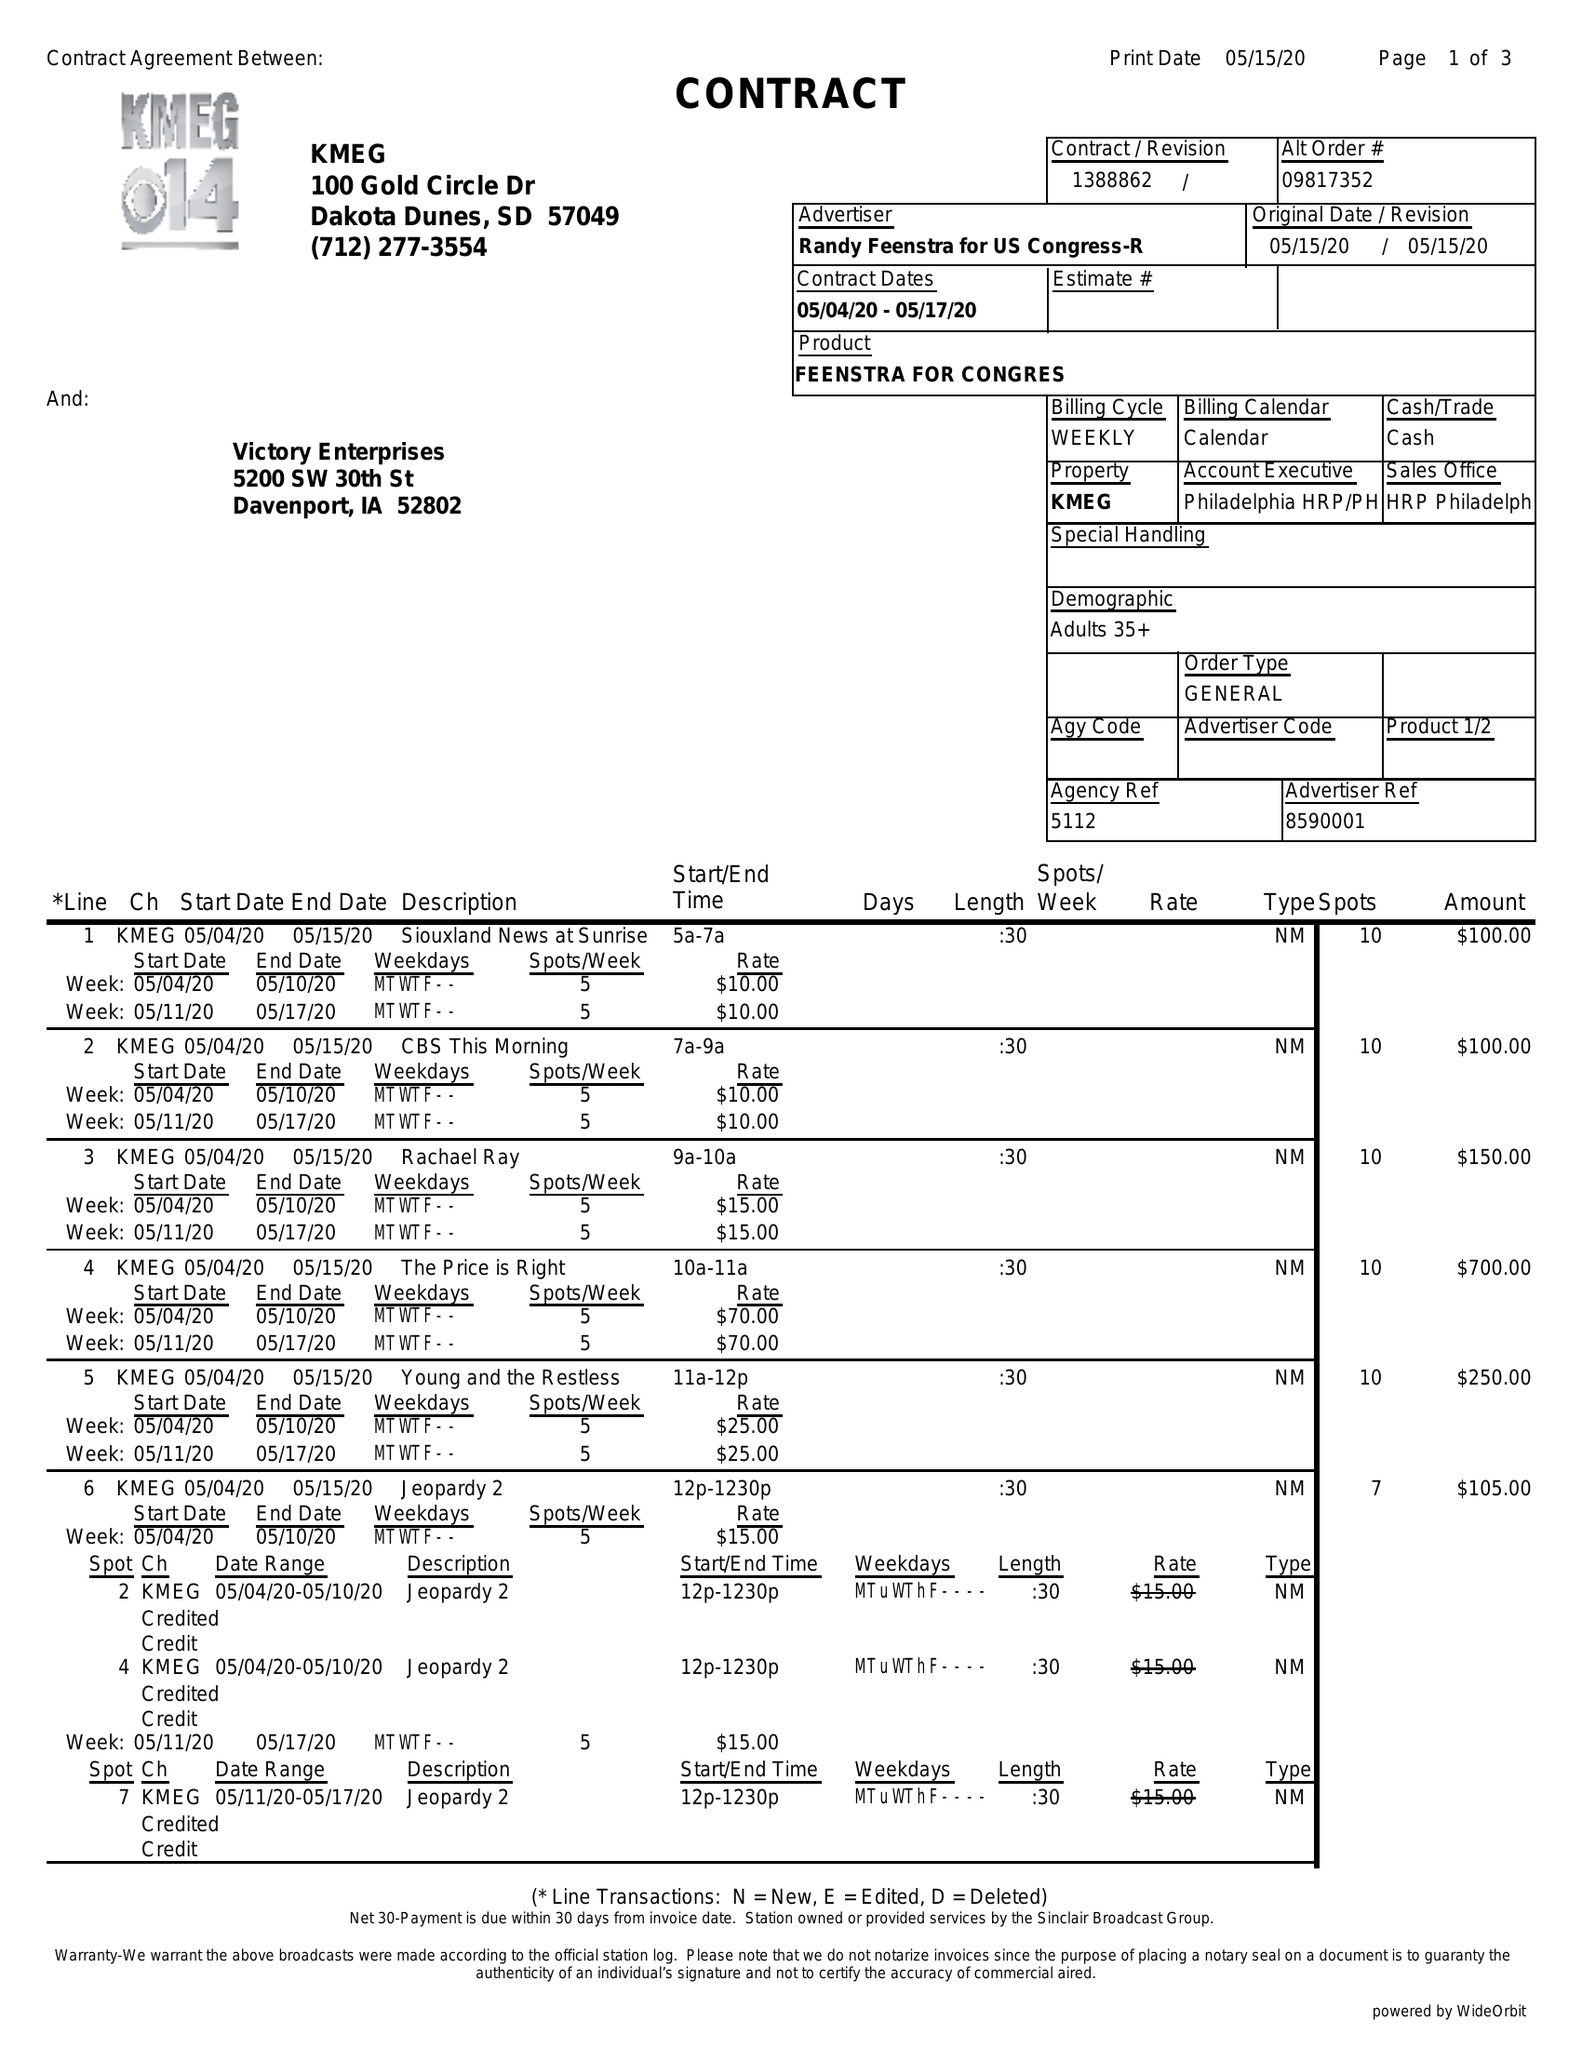What is the value for the advertiser?
Answer the question using a single word or phrase. RANDY FEENSTRA FOR US CONGRESS-R 